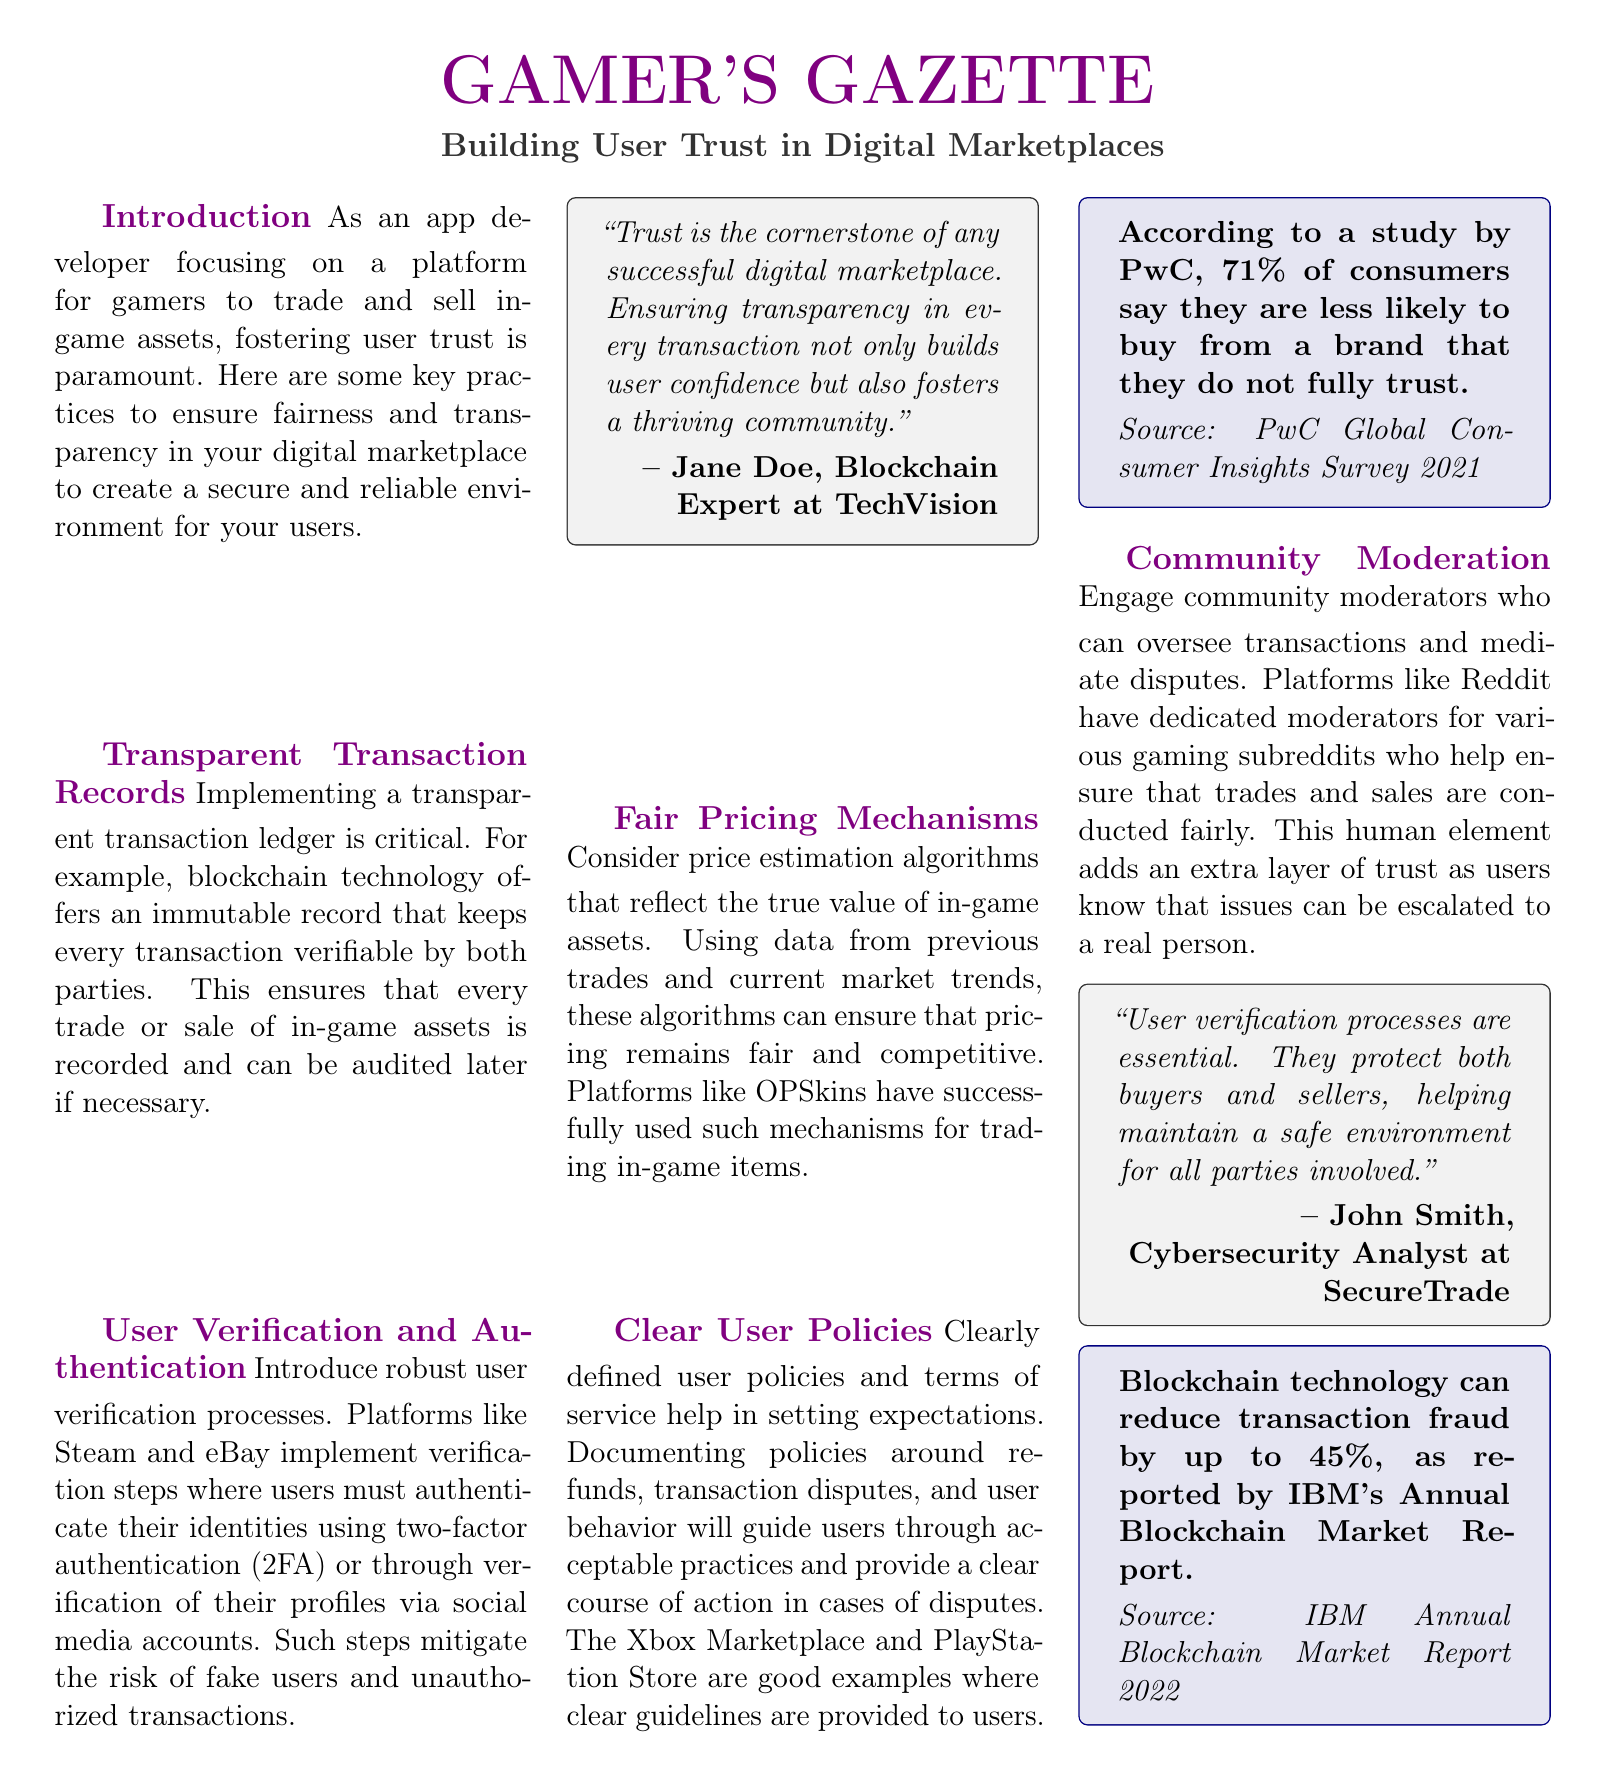what is the title of the document? The title of the document is mentioned at the top as "Building User Trust in Digital Marketplaces."
Answer: Building User Trust in Digital Marketplaces who is quoted regarding transparency in digital marketplaces? The document states, "Trust is the cornerstone of any successful digital marketplace," quoted by Jane Doe.
Answer: Jane Doe what percentage of consumers are less likely to buy from a brand they do not fully trust? The document cites a study by PwC indicating that 71% of consumers express skepticism towards untrustworthy brands.
Answer: 71% which technology is suggested to ensure transparent transaction records? The document highlights blockchain technology as an example that provides transparency in transaction records.
Answer: blockchain technology what user authentication method is used by platforms like Steam? The document mentions two-factor authentication (2FA) as a method for user authentication.
Answer: two-factor authentication (2FA) who provides insight on the importance of user verification processes? The document includes a quote from John Smith about the importance of user verification processes.
Answer: John Smith what gaming platforms are mentioned as examples for clear user policies? The document references the Xbox Marketplace and PlayStation Store as examples of platforms with clear user policies.
Answer: Xbox Marketplace and PlayStation Store what is the main purpose of community moderation in digital marketplaces? The document states that community moderation is intended to oversee transactions and mediate disputes.
Answer: oversee transactions and mediate disputes how can blockchain technology affect transaction fraud? The document states that blockchain technology can reduce transaction fraud by up to 45%.
Answer: up to 45% 